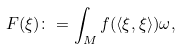Convert formula to latex. <formula><loc_0><loc_0><loc_500><loc_500>F ( \xi ) \colon = \int _ { M } f ( \langle \xi , \xi \rangle ) \omega ,</formula> 